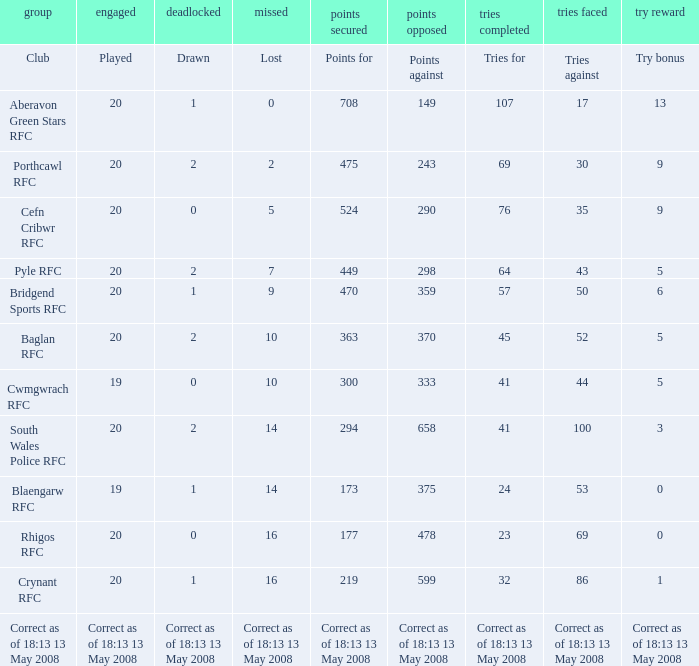What is the tries for when 52 was the tries against? 45.0. Could you parse the entire table? {'header': ['group', 'engaged', 'deadlocked', 'missed', 'points secured', 'points opposed', 'tries completed', 'tries faced', 'try reward'], 'rows': [['Club', 'Played', 'Drawn', 'Lost', 'Points for', 'Points against', 'Tries for', 'Tries against', 'Try bonus'], ['Aberavon Green Stars RFC', '20', '1', '0', '708', '149', '107', '17', '13'], ['Porthcawl RFC', '20', '2', '2', '475', '243', '69', '30', '9'], ['Cefn Cribwr RFC', '20', '0', '5', '524', '290', '76', '35', '9'], ['Pyle RFC', '20', '2', '7', '449', '298', '64', '43', '5'], ['Bridgend Sports RFC', '20', '1', '9', '470', '359', '57', '50', '6'], ['Baglan RFC', '20', '2', '10', '363', '370', '45', '52', '5'], ['Cwmgwrach RFC', '19', '0', '10', '300', '333', '41', '44', '5'], ['South Wales Police RFC', '20', '2', '14', '294', '658', '41', '100', '3'], ['Blaengarw RFC', '19', '1', '14', '173', '375', '24', '53', '0'], ['Rhigos RFC', '20', '0', '16', '177', '478', '23', '69', '0'], ['Crynant RFC', '20', '1', '16', '219', '599', '32', '86', '1'], ['Correct as of 18:13 13 May 2008', 'Correct as of 18:13 13 May 2008', 'Correct as of 18:13 13 May 2008', 'Correct as of 18:13 13 May 2008', 'Correct as of 18:13 13 May 2008', 'Correct as of 18:13 13 May 2008', 'Correct as of 18:13 13 May 2008', 'Correct as of 18:13 13 May 2008', 'Correct as of 18:13 13 May 2008']]} 